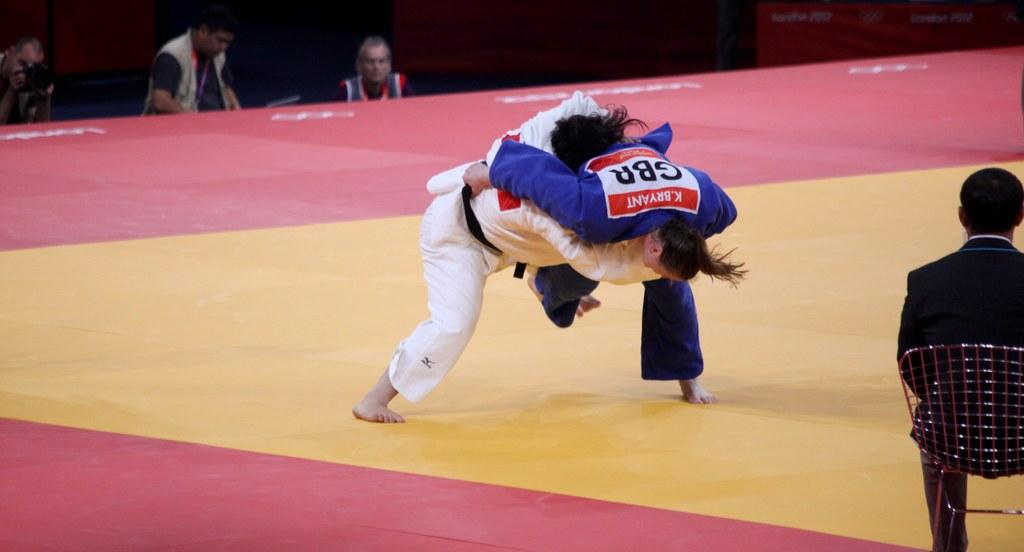Provide a one-sentence caption for the provided image. K Byrant wrestles a person wearing white clothing. 